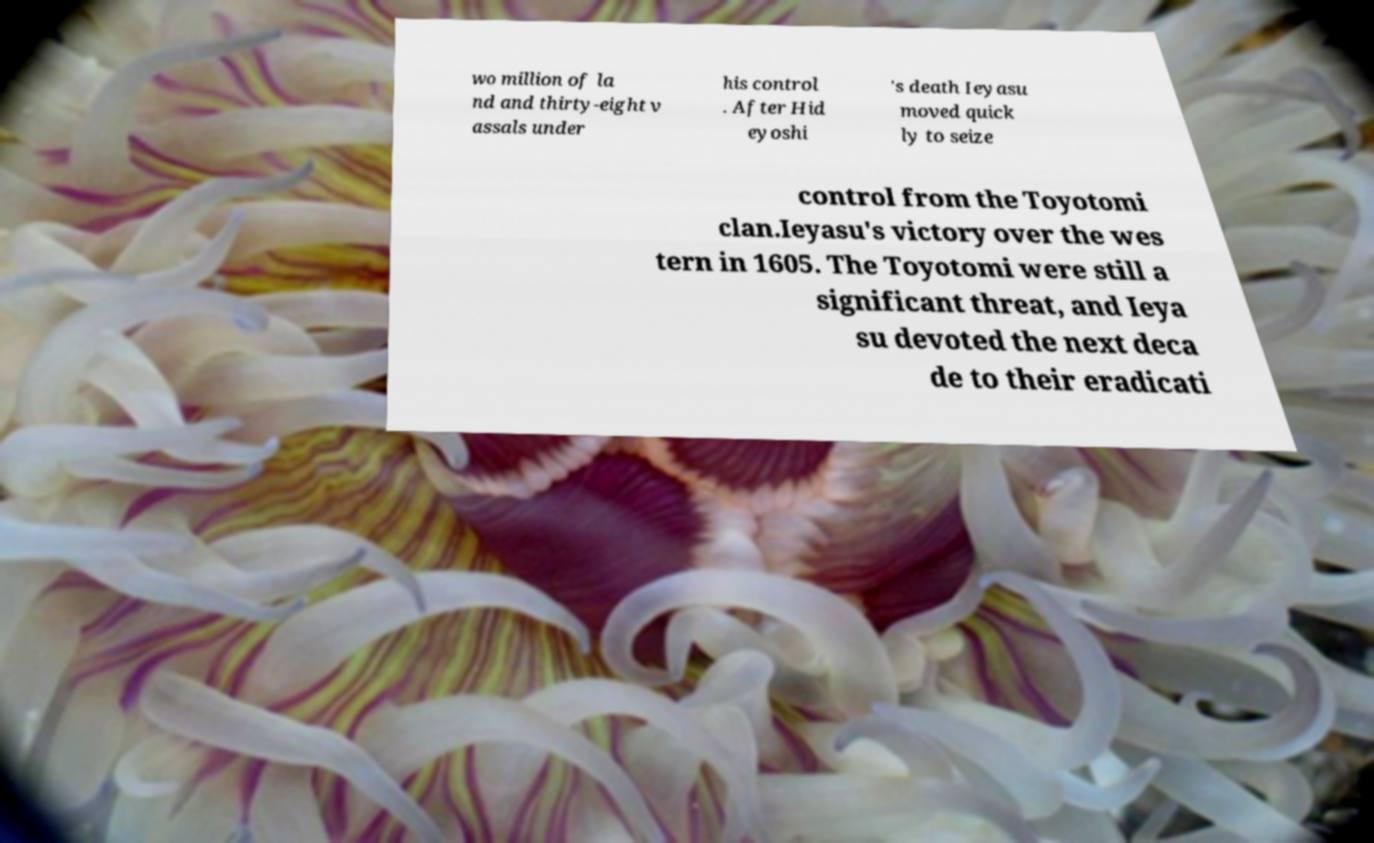For documentation purposes, I need the text within this image transcribed. Could you provide that? wo million of la nd and thirty-eight v assals under his control . After Hid eyoshi 's death Ieyasu moved quick ly to seize control from the Toyotomi clan.Ieyasu's victory over the wes tern in 1605. The Toyotomi were still a significant threat, and Ieya su devoted the next deca de to their eradicati 